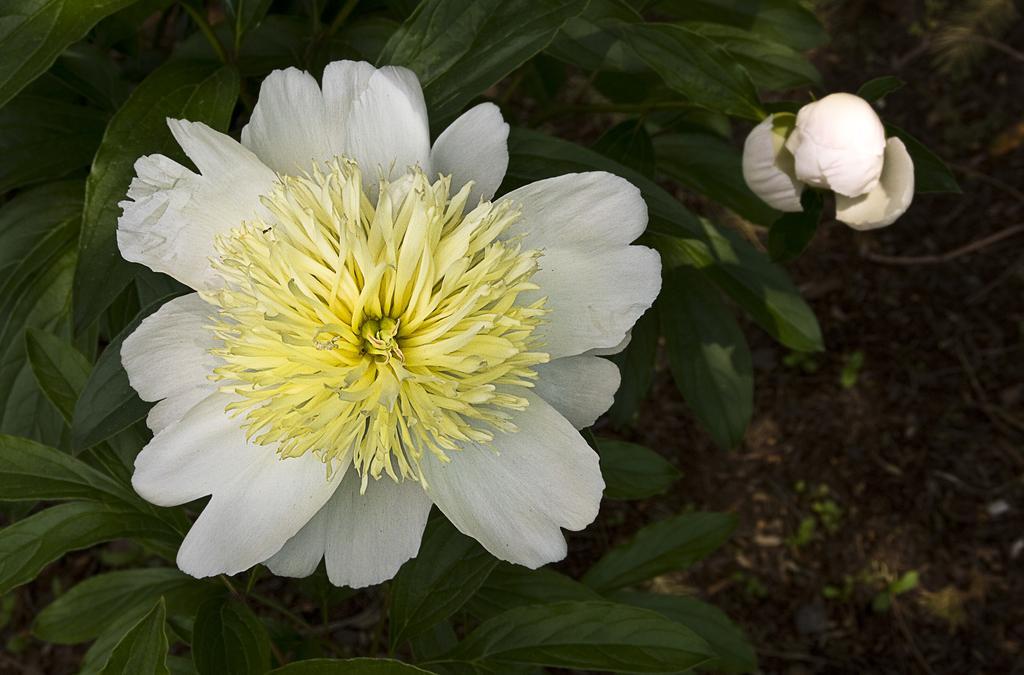In one or two sentences, can you explain what this image depicts? In this image there are two flowers, at the background of the image there is a plant. 